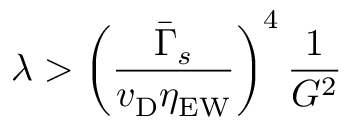<formula> <loc_0><loc_0><loc_500><loc_500>\lambda > \left ( \frac { { \bar { \Gamma } } _ { s } } { v _ { D } \eta _ { E W } } \right ) ^ { 4 } \frac { 1 } { G ^ { 2 } }</formula> 